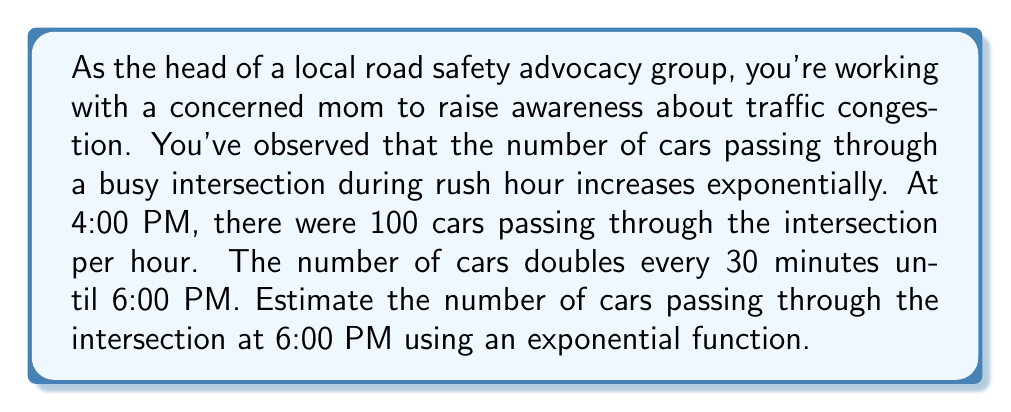Solve this math problem. Let's approach this step-by-step:

1) First, we need to identify the components of our exponential function:
   - Initial value (a): 100 cars at 4:00 PM
   - Growth factor (b): 2 (doubles every 30 minutes)
   - Time (t): 2 hours (from 4:00 PM to 6:00 PM)

2) The general form of an exponential function is:

   $$ f(t) = a \cdot b^t $$

   Where $f(t)$ is the number of cars at time $t$, $a$ is the initial value, $b$ is the growth factor, and $t$ is the time in hours.

3) However, we need to adjust our growth factor. It doubles every 30 minutes, which means it doubles 4 times in 2 hours. So, our actual growth factor for 1 hour is $\sqrt{2}$.

4) Now we can set up our function:

   $$ f(t) = 100 \cdot (\sqrt{2})^{2t} $$

5) To find the number of cars at 6:00 PM, we substitute $t = 2$:

   $$ f(2) = 100 \cdot (\sqrt{2})^{2(2)} = 100 \cdot (\sqrt{2})^4 = 100 \cdot 2^2 = 100 \cdot 4 = 400 $$

Therefore, at 6:00 PM, we estimate there will be 400 cars passing through the intersection per hour.
Answer: 400 cars per hour 